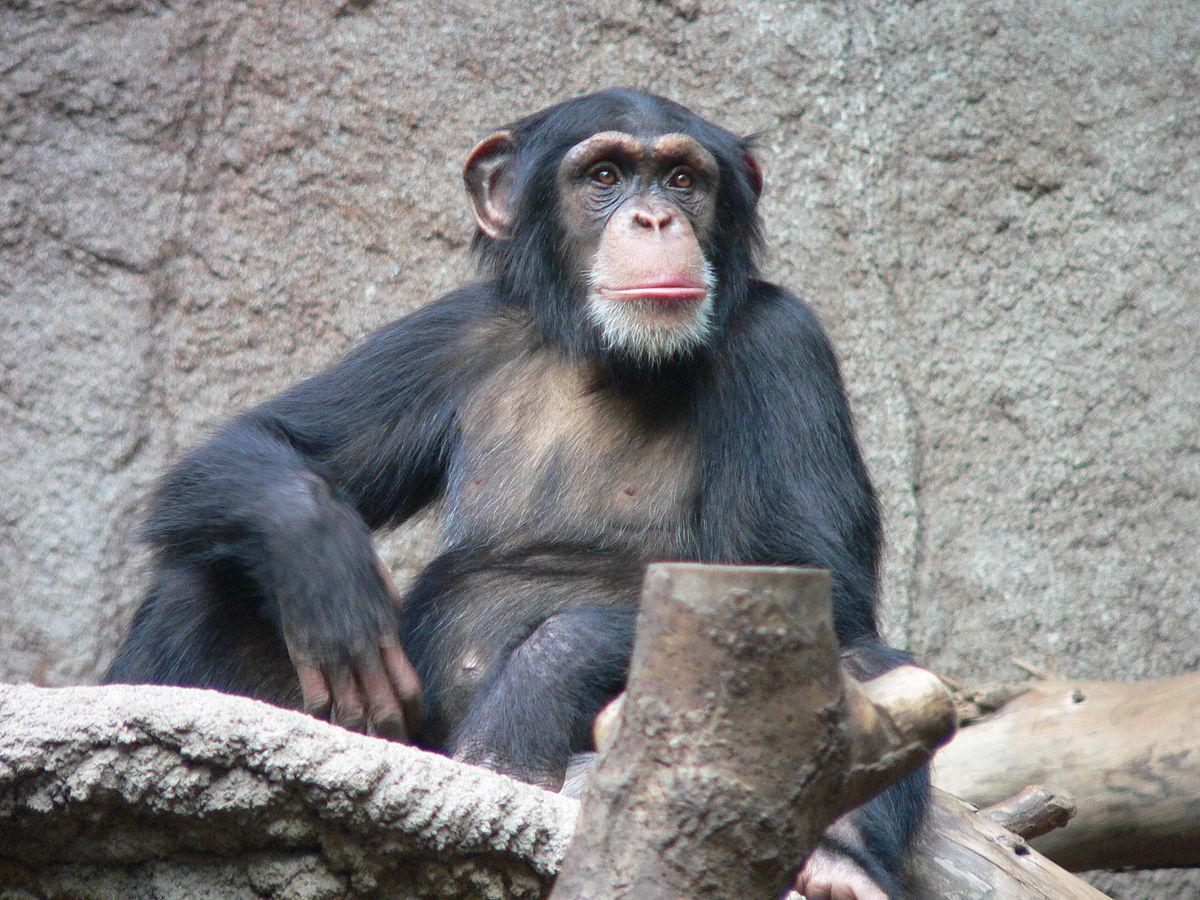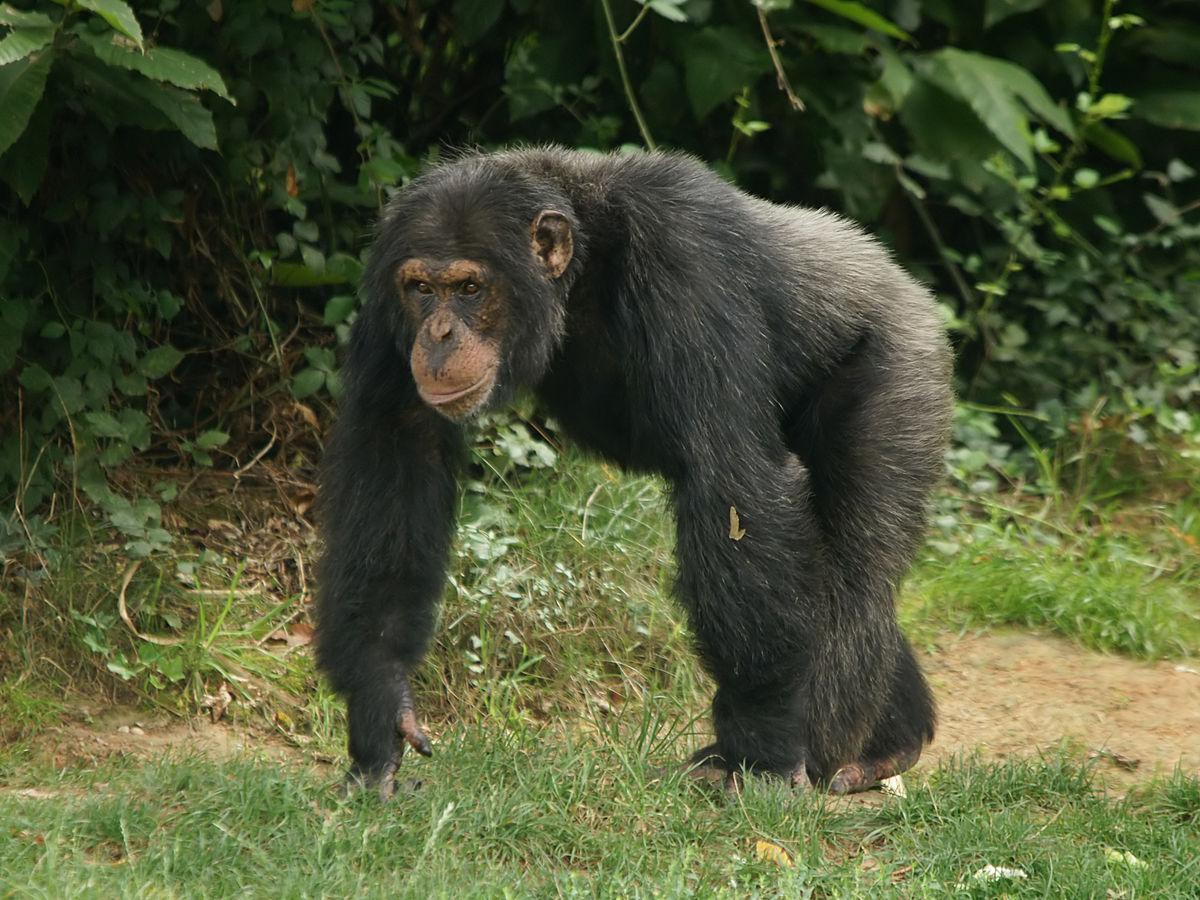The first image is the image on the left, the second image is the image on the right. Examine the images to the left and right. Is the description "At least one of the images contains exactly three monkeys." accurate? Answer yes or no. No. 